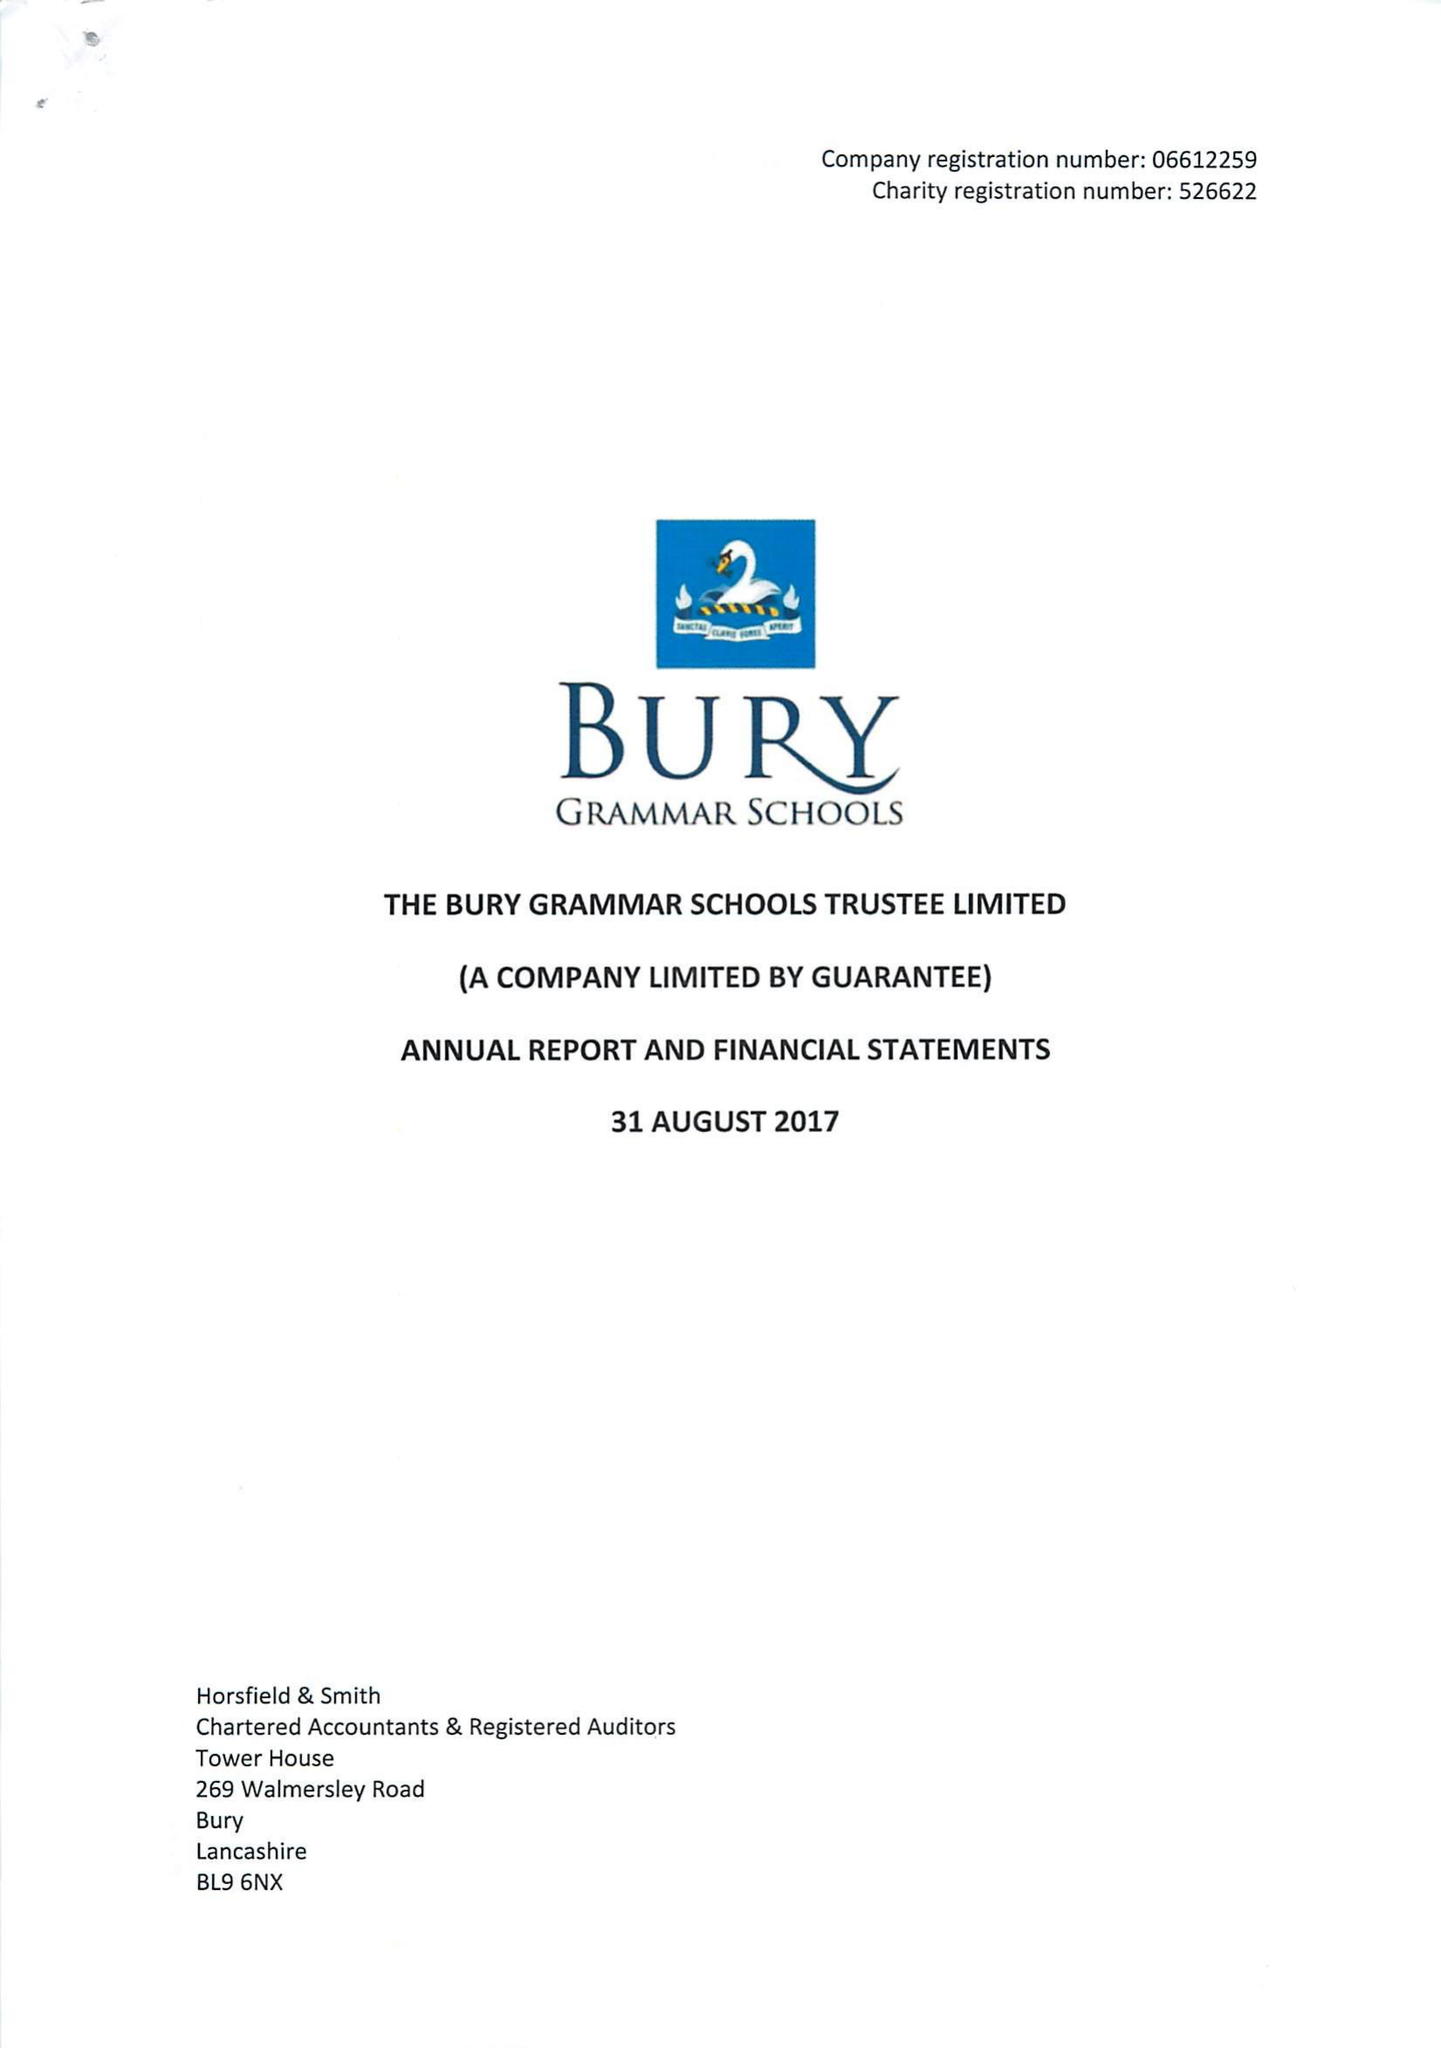What is the value for the address__street_line?
Answer the question using a single word or phrase. BRIDGE ROAD 